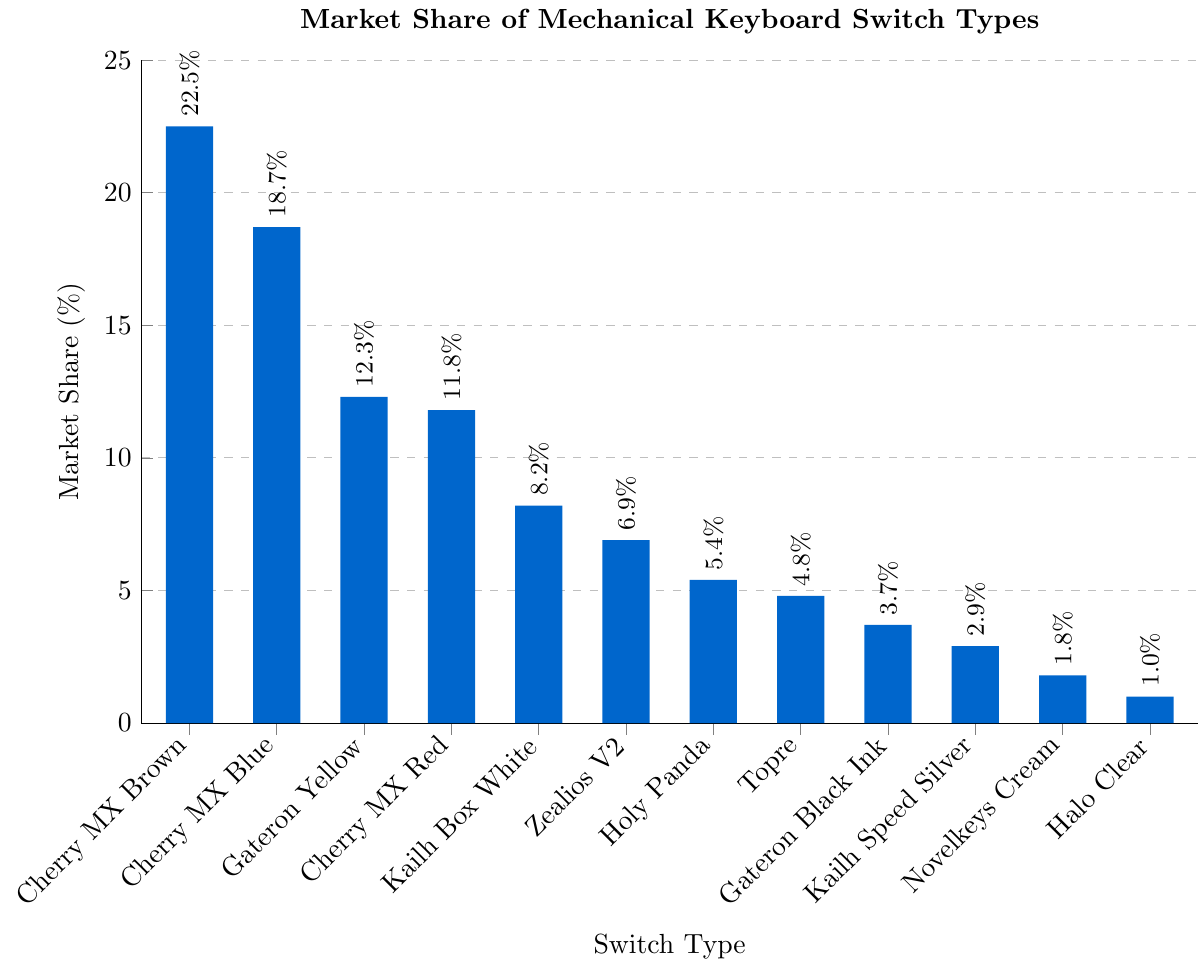What is the switch type with the highest market share? The switch type with the highest market share can be identified by looking at the tallest bar in the chart, which corresponds to Cherry MX Brown.
Answer: Cherry MX Brown What is the combined market share of Cherry MX Blue and Cherry MX Red? The market share of Cherry MX Blue is 18.7% and Cherry MX Red is 11.8%. Adding these two values together, 18.7 + 11.8 = 30.5.
Answer: 30.5% Which switch type has a market share closest to 10%? Inspecting the chart, Gateron Yellow has a market share of 12.3% and Cherry MX Red has a market share of 11.8%, both are close. However, Cherry MX Red is nearest to 10%.
Answer: Cherry MX Red How much greater is the market share of Cherry MX Brown compared to Gateron Black Ink? The market share of Cherry MX Brown is 22.5% and Gateron Black Ink is 3.7%. Subtracting these two values, 22.5 - 3.7 = 18.8.
Answer: 18.8% What switch types have a market share greater than 5% but less than 20%? By inspecting the heights of the bars and their corresponding labels, Cherry MX Blue (18.7%), Gateron Yellow (12.3%), Cherry MX Red (11.8%), Kailh Box White (8.2%), and Zealios V2 (6.9%) fit the criteria.
Answer: Cherry MX Blue, Gateron Yellow, Cherry MX Red, Kailh Box White, Zealios V2 What is the total market share of the switches with less than 5%? Summing the market shares of Holy Panda (5.4% which is just over the limit), Topre (4.8%), Gateron Black Ink (3.7%), Kailh Speed Silver (2.9%), Novelkeys Cream (1.8%), and Halo Clear (1.0%), the total is 4.8 + 3.7 + 2.9 + 1.8 + 1.0 = 14.2.
Answer: 14.2% Which switch type has the least market share? The shortest bar in the chart corresponds to Halo Clear, indicating it has the least market share.
Answer: Halo Clear How does the market share of Zealios V2 compare to Topre? The market share of Zealios V2 is 6.9%, while Topre is 4.8%. Zealios V2 has a higher market share than Topre.
Answer: Zealios V2 is greater What is the average market share of the top three switch types? The top three switch types are Cherry MX Brown (22.5%), Cherry MX Blue (18.7%), and Gateron Yellow (12.3%). The average is calculated by summing these values and dividing by 3: (22.5 + 18.7 + 12.3) / 3 = 53.5 / 3 = 17.83.
Answer: 17.83% What percentage of the market is held by switches from Cherry MX? Adding the market shares of Cherry MX Brown (22.5%), Cherry MX Blue (18.7%), and Cherry MX Red (11.8%) gives: 22.5 + 18.7 + 11.8 = 53.0%.
Answer: 53.0% 